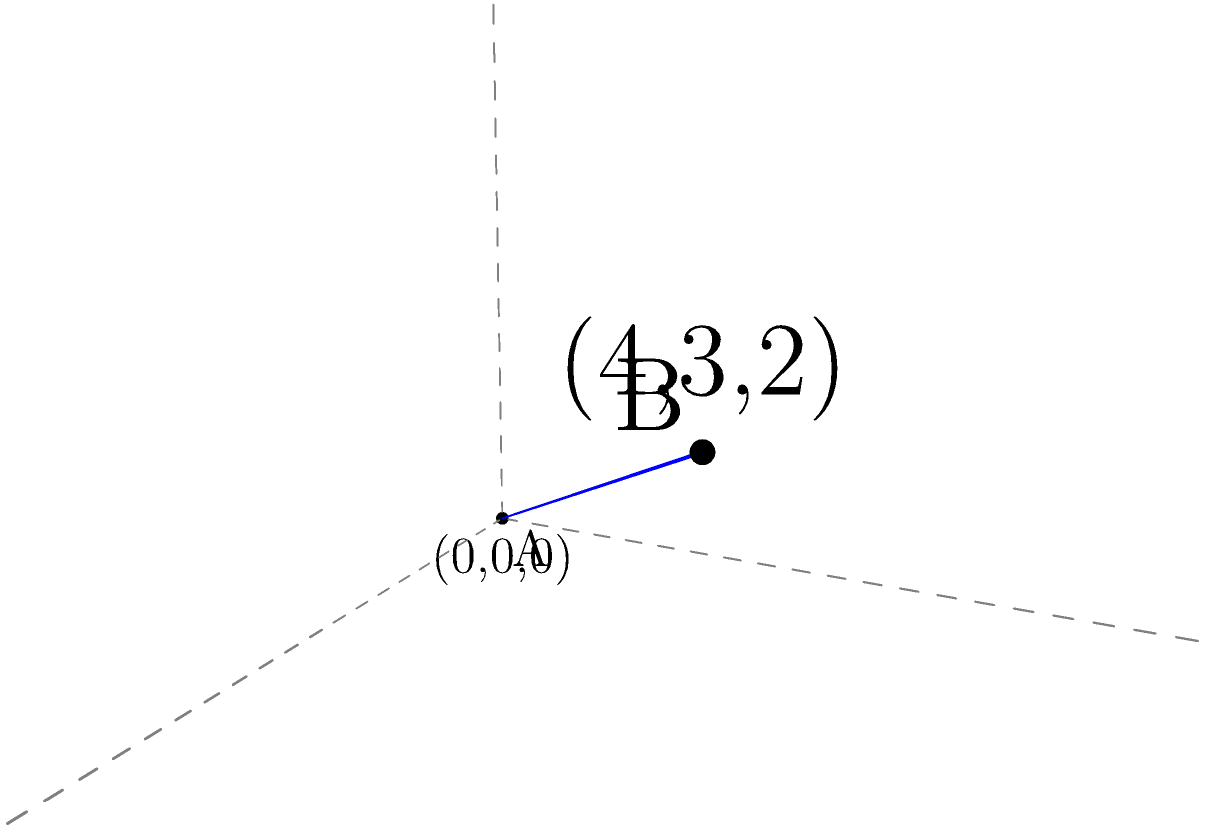Two database servers are located in a 3D space. Server A is at coordinates (0,0,0) and Server B is at coordinates (4,3,2). Calculate the minimum distance between these two servers to ensure optimal network configuration and data transfer rates. To find the minimum distance between two points in 3D space, we can use the distance formula derived from the Pythagorean theorem in three dimensions:

1) The distance formula in 3D is:
   $$d = \sqrt{(x_2-x_1)^2 + (y_2-y_1)^2 + (z_2-z_1)^2}$$

2) We have:
   Point A (Server A): $(x_1,y_1,z_1) = (0,0,0)$
   Point B (Server B): $(x_2,y_2,z_2) = (4,3,2)$

3) Substituting these values into the formula:
   $$d = \sqrt{(4-0)^2 + (3-0)^2 + (2-0)^2}$$

4) Simplify:
   $$d = \sqrt{4^2 + 3^2 + 2^2}$$

5) Calculate:
   $$d = \sqrt{16 + 9 + 4}$$
   $$d = \sqrt{29}$$

6) The square root of 29 is approximately 5.385 units.

Therefore, the minimum distance between the two database servers is $\sqrt{29}$ units or approximately 5.385 units.
Answer: $\sqrt{29}$ units 